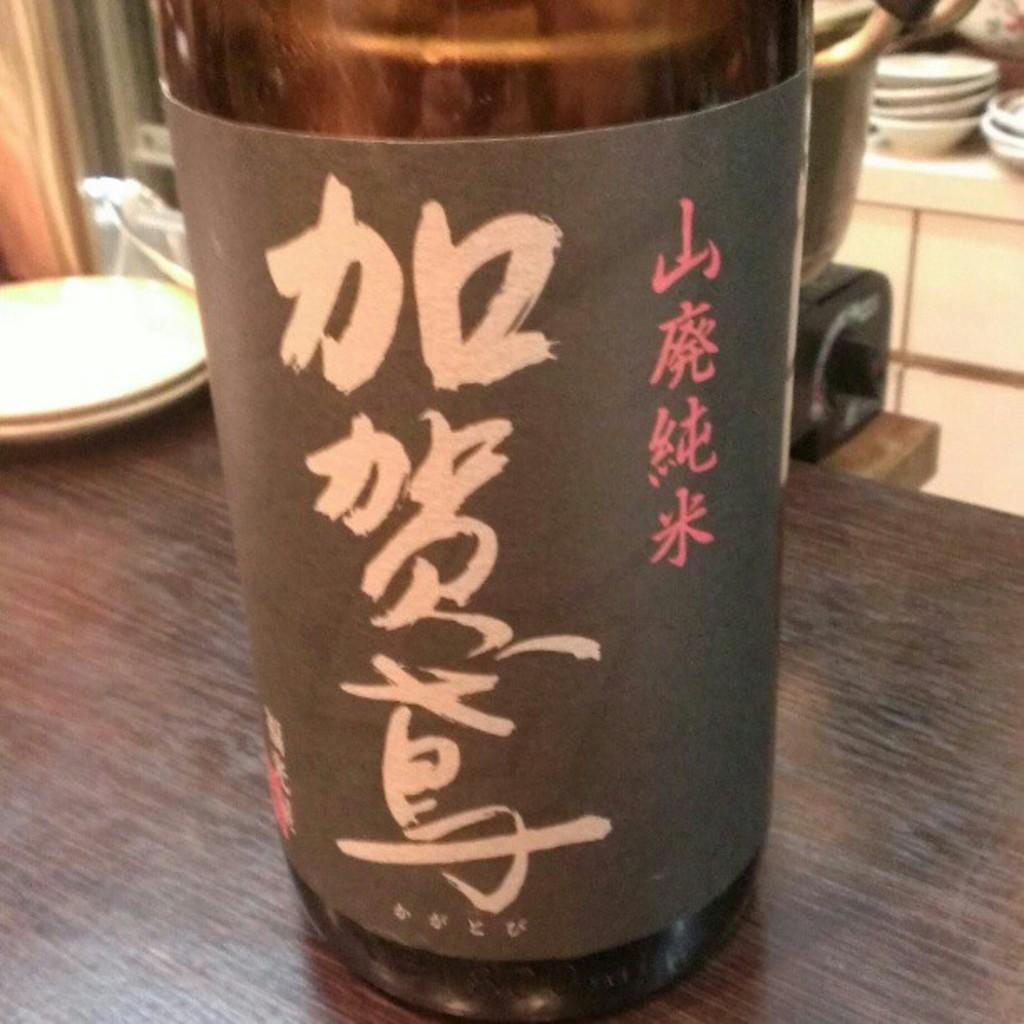What is on the table in the image? There is a bottle and two saucers on the table in the image. Can you describe the background of the image? There is another table in the background with bowls and other objects on it. How many tables are visible in the image? There are two tables visible in the image. How many bricks are stacked on the table in the image? There are no bricks present on the table in the image. What type of test is being conducted in the image? There is no test being conducted in the image; it only shows a table with a bottle and two saucers. 